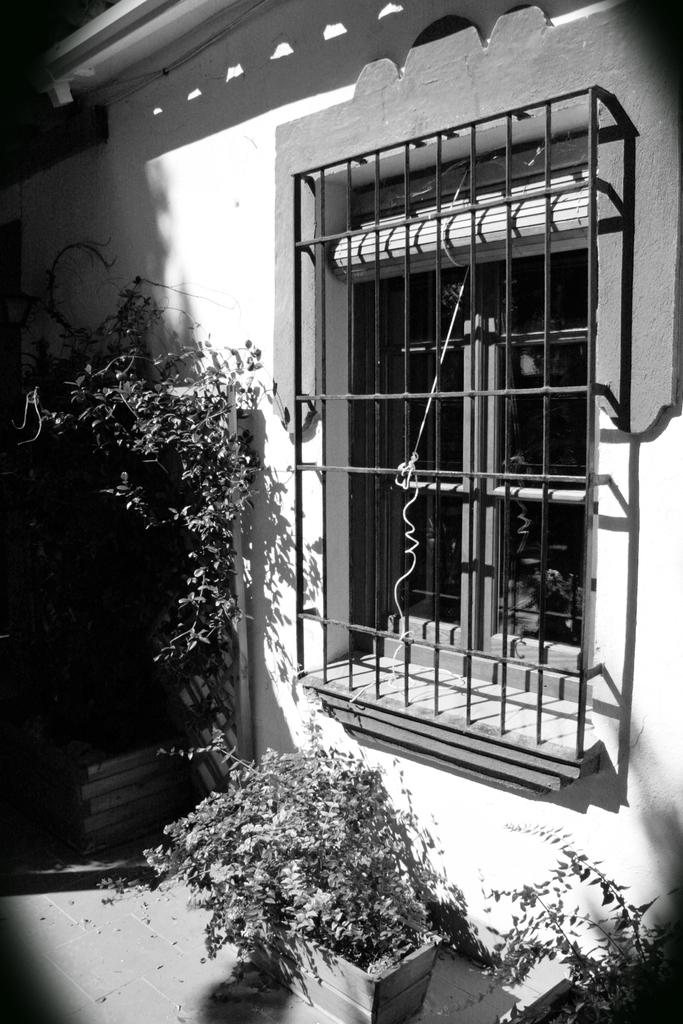What is the color scheme of the image? A: The image is black and white. What can be seen in the flower pots in the image? There are plants in the flower pots in the image. What type of architectural feature is present in the image? There is a window with glass doors in the image. What material is used for the grill in the image? The grill in the image is made of iron. What type of surface is depicted in the image? The image appears to depict a building wall. Can you tell me how many mountains are visible in the image? There are no mountains visible in the image; it depicts a building wall with flower pots, a window, and an iron grill. What type of family is shown interacting with the plants in the image? There is no family present in the image; it only shows flower pots with plants, a window, and an iron grill. 